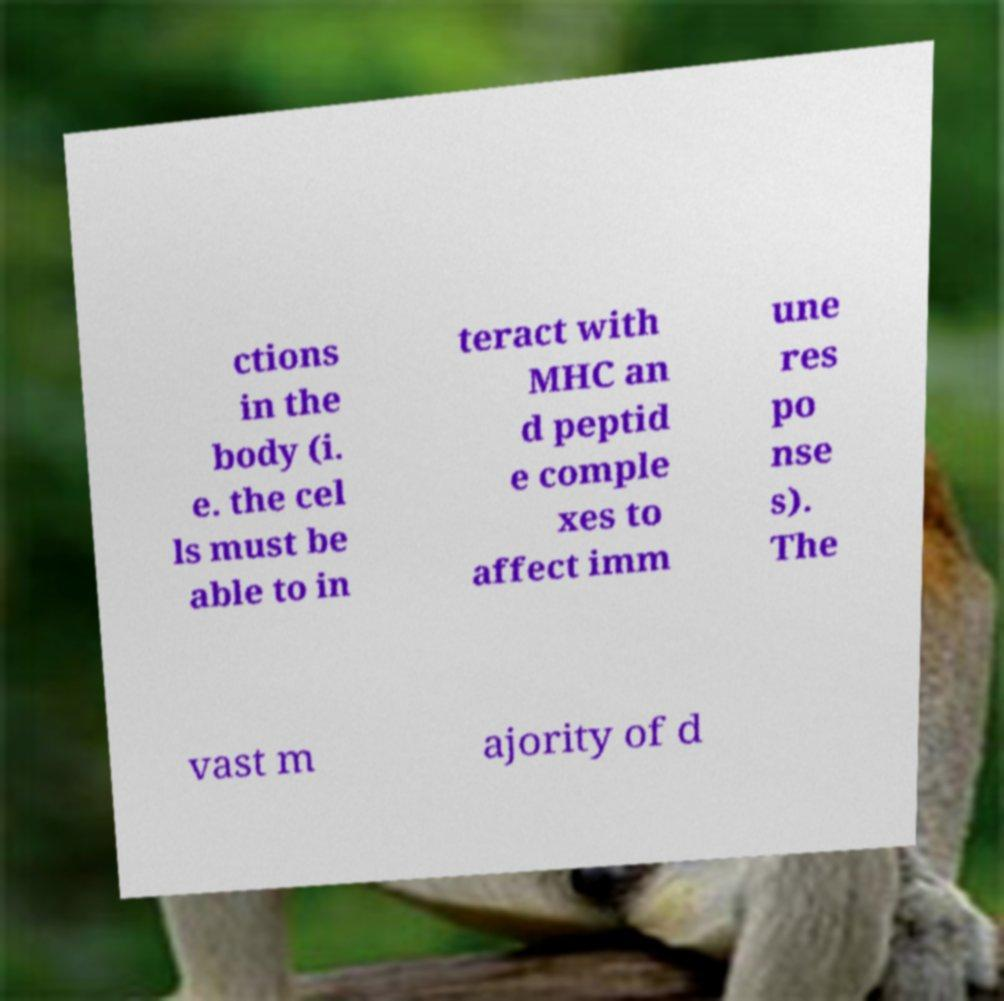What messages or text are displayed in this image? I need them in a readable, typed format. ctions in the body (i. e. the cel ls must be able to in teract with MHC an d peptid e comple xes to affect imm une res po nse s). The vast m ajority of d 